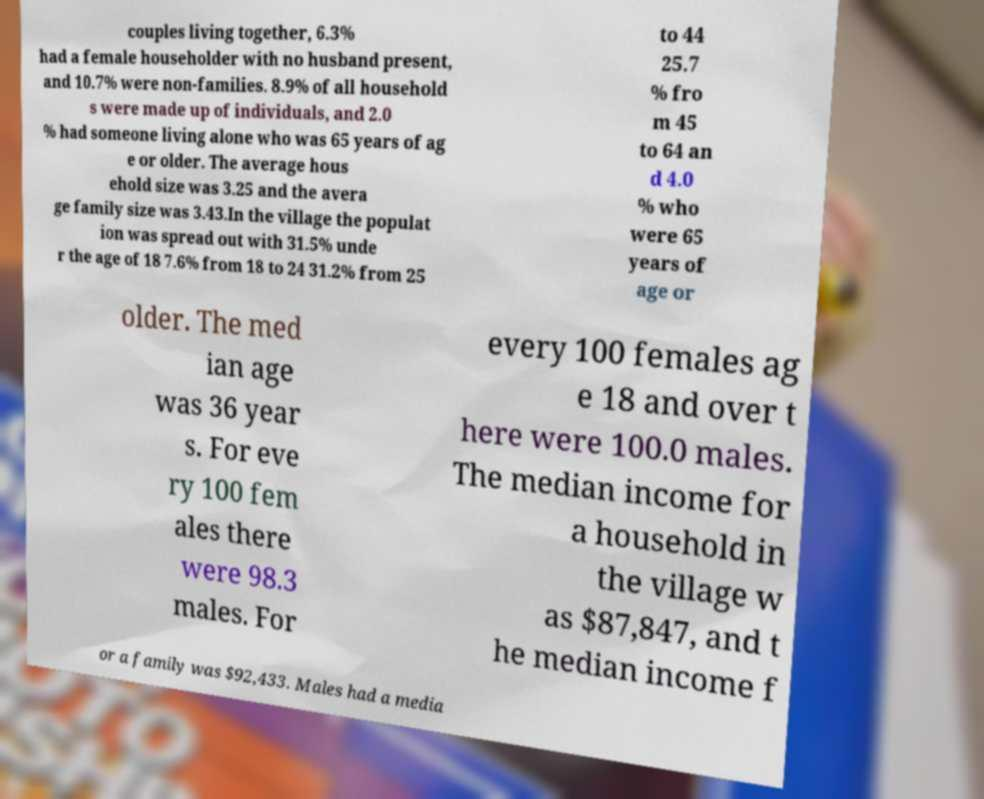I need the written content from this picture converted into text. Can you do that? couples living together, 6.3% had a female householder with no husband present, and 10.7% were non-families. 8.9% of all household s were made up of individuals, and 2.0 % had someone living alone who was 65 years of ag e or older. The average hous ehold size was 3.25 and the avera ge family size was 3.43.In the village the populat ion was spread out with 31.5% unde r the age of 18 7.6% from 18 to 24 31.2% from 25 to 44 25.7 % fro m 45 to 64 an d 4.0 % who were 65 years of age or older. The med ian age was 36 year s. For eve ry 100 fem ales there were 98.3 males. For every 100 females ag e 18 and over t here were 100.0 males. The median income for a household in the village w as $87,847, and t he median income f or a family was $92,433. Males had a media 